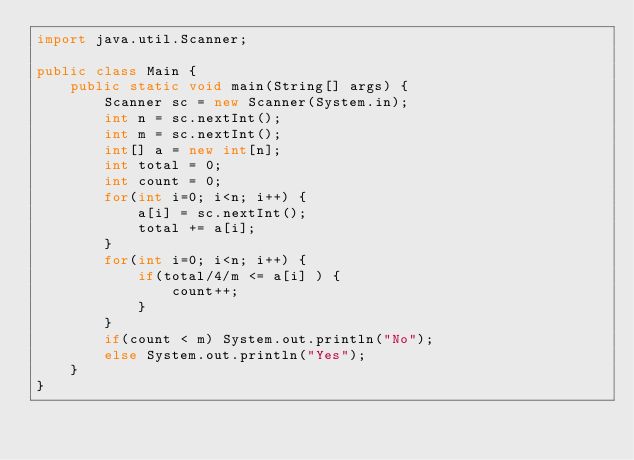Convert code to text. <code><loc_0><loc_0><loc_500><loc_500><_Java_>import java.util.Scanner;

public class Main {
    public static void main(String[] args) {
        Scanner sc = new Scanner(System.in);
        int n = sc.nextInt();
        int m = sc.nextInt();
        int[] a = new int[n];
        int total = 0;
        int count = 0;
        for(int i=0; i<n; i++) {
            a[i] = sc.nextInt();
            total += a[i];
        }
        for(int i=0; i<n; i++) {
            if(total/4/m <= a[i] ) {
                count++;
            }
        }
        if(count < m) System.out.println("No");
        else System.out.println("Yes");
    }
}</code> 